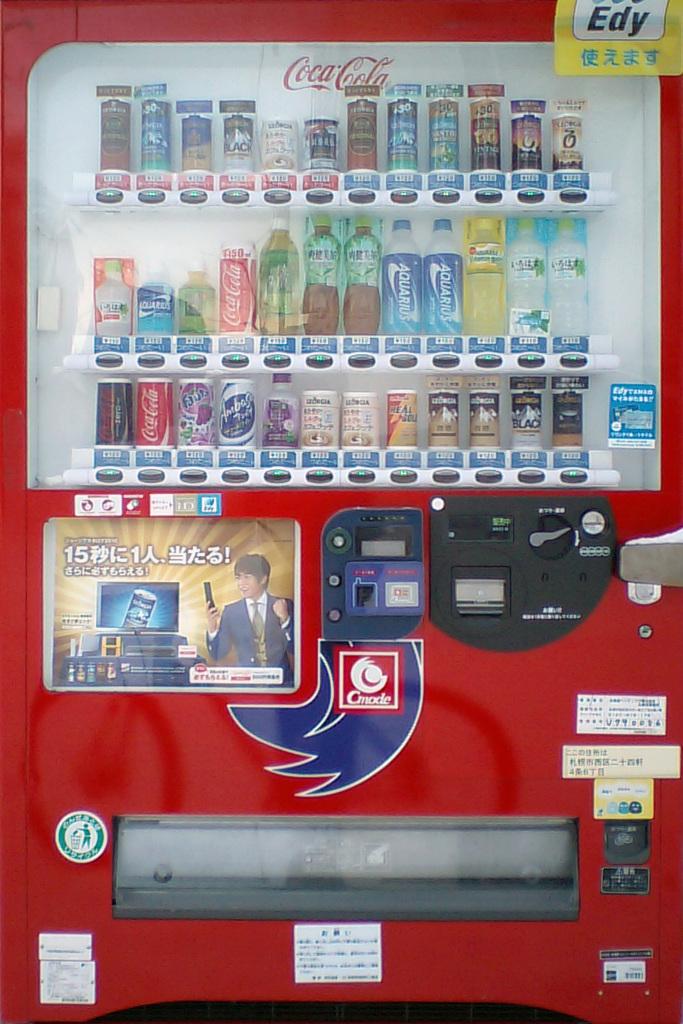What brand of soda is in the machine?
Give a very brief answer. Coca cola. What are the three letters in black on the upper right of the machine?
Your answer should be very brief. Edy. 